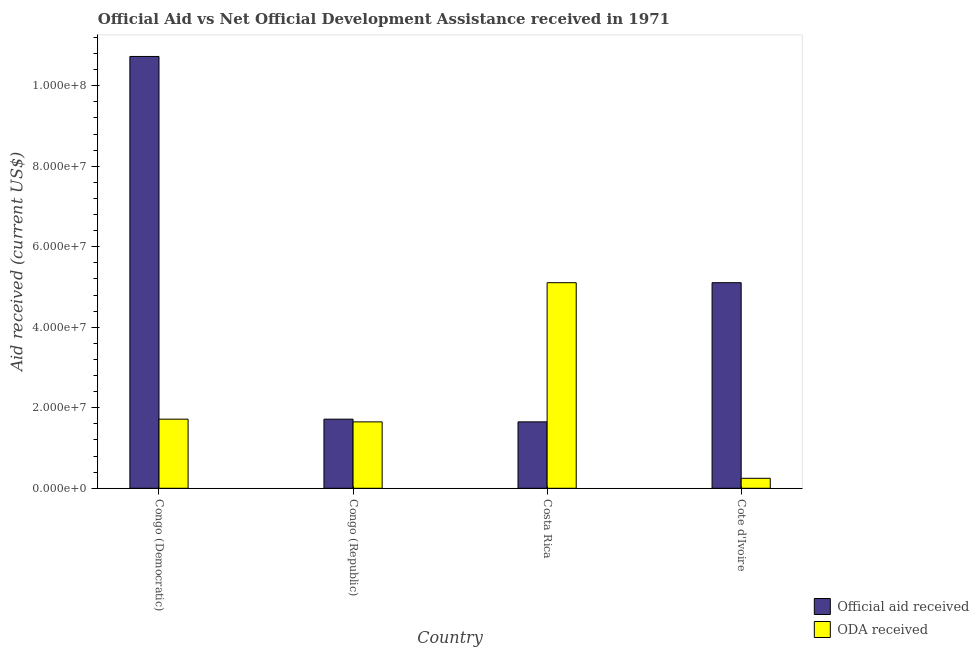How many different coloured bars are there?
Offer a terse response. 2. How many groups of bars are there?
Offer a terse response. 4. Are the number of bars on each tick of the X-axis equal?
Ensure brevity in your answer.  Yes. How many bars are there on the 1st tick from the left?
Your answer should be very brief. 2. What is the label of the 1st group of bars from the left?
Provide a succinct answer. Congo (Democratic). What is the official aid received in Congo (Republic)?
Ensure brevity in your answer.  1.72e+07. Across all countries, what is the maximum official aid received?
Keep it short and to the point. 1.07e+08. Across all countries, what is the minimum oda received?
Keep it short and to the point. 2.48e+06. In which country was the official aid received maximum?
Your answer should be very brief. Congo (Democratic). What is the total official aid received in the graph?
Provide a short and direct response. 1.92e+08. What is the difference between the official aid received in Congo (Republic) and that in Costa Rica?
Give a very brief answer. 6.70e+05. What is the average oda received per country?
Keep it short and to the point. 2.18e+07. What is the difference between the oda received and official aid received in Cote d'Ivoire?
Ensure brevity in your answer.  -4.86e+07. What is the ratio of the oda received in Costa Rica to that in Cote d'Ivoire?
Provide a succinct answer. 20.59. What is the difference between the highest and the second highest oda received?
Ensure brevity in your answer.  3.39e+07. What is the difference between the highest and the lowest oda received?
Give a very brief answer. 4.86e+07. In how many countries, is the official aid received greater than the average official aid received taken over all countries?
Your answer should be very brief. 2. Is the sum of the oda received in Congo (Democratic) and Cote d'Ivoire greater than the maximum official aid received across all countries?
Offer a very short reply. No. What does the 2nd bar from the left in Costa Rica represents?
Your response must be concise. ODA received. What does the 2nd bar from the right in Cote d'Ivoire represents?
Your answer should be compact. Official aid received. Does the graph contain any zero values?
Your answer should be very brief. No. Where does the legend appear in the graph?
Make the answer very short. Bottom right. What is the title of the graph?
Make the answer very short. Official Aid vs Net Official Development Assistance received in 1971 . What is the label or title of the X-axis?
Offer a terse response. Country. What is the label or title of the Y-axis?
Make the answer very short. Aid received (current US$). What is the Aid received (current US$) in Official aid received in Congo (Democratic)?
Provide a succinct answer. 1.07e+08. What is the Aid received (current US$) in ODA received in Congo (Democratic)?
Provide a succinct answer. 1.72e+07. What is the Aid received (current US$) of Official aid received in Congo (Republic)?
Provide a succinct answer. 1.72e+07. What is the Aid received (current US$) of ODA received in Congo (Republic)?
Make the answer very short. 1.65e+07. What is the Aid received (current US$) in Official aid received in Costa Rica?
Keep it short and to the point. 1.65e+07. What is the Aid received (current US$) in ODA received in Costa Rica?
Offer a very short reply. 5.11e+07. What is the Aid received (current US$) in Official aid received in Cote d'Ivoire?
Offer a very short reply. 5.11e+07. What is the Aid received (current US$) of ODA received in Cote d'Ivoire?
Your answer should be compact. 2.48e+06. Across all countries, what is the maximum Aid received (current US$) in Official aid received?
Provide a short and direct response. 1.07e+08. Across all countries, what is the maximum Aid received (current US$) in ODA received?
Your answer should be compact. 5.11e+07. Across all countries, what is the minimum Aid received (current US$) in Official aid received?
Provide a succinct answer. 1.65e+07. Across all countries, what is the minimum Aid received (current US$) of ODA received?
Your answer should be very brief. 2.48e+06. What is the total Aid received (current US$) in Official aid received in the graph?
Make the answer very short. 1.92e+08. What is the total Aid received (current US$) of ODA received in the graph?
Offer a very short reply. 8.72e+07. What is the difference between the Aid received (current US$) in Official aid received in Congo (Democratic) and that in Congo (Republic)?
Provide a short and direct response. 9.01e+07. What is the difference between the Aid received (current US$) of ODA received in Congo (Democratic) and that in Congo (Republic)?
Offer a very short reply. 6.70e+05. What is the difference between the Aid received (current US$) of Official aid received in Congo (Democratic) and that in Costa Rica?
Offer a terse response. 9.08e+07. What is the difference between the Aid received (current US$) in ODA received in Congo (Democratic) and that in Costa Rica?
Your response must be concise. -3.39e+07. What is the difference between the Aid received (current US$) in Official aid received in Congo (Democratic) and that in Cote d'Ivoire?
Keep it short and to the point. 5.62e+07. What is the difference between the Aid received (current US$) in ODA received in Congo (Democratic) and that in Cote d'Ivoire?
Give a very brief answer. 1.47e+07. What is the difference between the Aid received (current US$) of Official aid received in Congo (Republic) and that in Costa Rica?
Your answer should be compact. 6.70e+05. What is the difference between the Aid received (current US$) of ODA received in Congo (Republic) and that in Costa Rica?
Ensure brevity in your answer.  -3.46e+07. What is the difference between the Aid received (current US$) in Official aid received in Congo (Republic) and that in Cote d'Ivoire?
Make the answer very short. -3.39e+07. What is the difference between the Aid received (current US$) in ODA received in Congo (Republic) and that in Cote d'Ivoire?
Your answer should be very brief. 1.40e+07. What is the difference between the Aid received (current US$) of Official aid received in Costa Rica and that in Cote d'Ivoire?
Your response must be concise. -3.46e+07. What is the difference between the Aid received (current US$) of ODA received in Costa Rica and that in Cote d'Ivoire?
Provide a succinct answer. 4.86e+07. What is the difference between the Aid received (current US$) in Official aid received in Congo (Democratic) and the Aid received (current US$) in ODA received in Congo (Republic)?
Make the answer very short. 9.08e+07. What is the difference between the Aid received (current US$) in Official aid received in Congo (Democratic) and the Aid received (current US$) in ODA received in Costa Rica?
Your response must be concise. 5.62e+07. What is the difference between the Aid received (current US$) of Official aid received in Congo (Democratic) and the Aid received (current US$) of ODA received in Cote d'Ivoire?
Provide a succinct answer. 1.05e+08. What is the difference between the Aid received (current US$) of Official aid received in Congo (Republic) and the Aid received (current US$) of ODA received in Costa Rica?
Your response must be concise. -3.39e+07. What is the difference between the Aid received (current US$) in Official aid received in Congo (Republic) and the Aid received (current US$) in ODA received in Cote d'Ivoire?
Keep it short and to the point. 1.47e+07. What is the difference between the Aid received (current US$) of Official aid received in Costa Rica and the Aid received (current US$) of ODA received in Cote d'Ivoire?
Keep it short and to the point. 1.40e+07. What is the average Aid received (current US$) in Official aid received per country?
Give a very brief answer. 4.80e+07. What is the average Aid received (current US$) in ODA received per country?
Your answer should be compact. 2.18e+07. What is the difference between the Aid received (current US$) in Official aid received and Aid received (current US$) in ODA received in Congo (Democratic)?
Your answer should be very brief. 9.01e+07. What is the difference between the Aid received (current US$) of Official aid received and Aid received (current US$) of ODA received in Congo (Republic)?
Make the answer very short. 6.70e+05. What is the difference between the Aid received (current US$) of Official aid received and Aid received (current US$) of ODA received in Costa Rica?
Your answer should be very brief. -3.46e+07. What is the difference between the Aid received (current US$) in Official aid received and Aid received (current US$) in ODA received in Cote d'Ivoire?
Offer a very short reply. 4.86e+07. What is the ratio of the Aid received (current US$) in Official aid received in Congo (Democratic) to that in Congo (Republic)?
Offer a very short reply. 6.25. What is the ratio of the Aid received (current US$) in ODA received in Congo (Democratic) to that in Congo (Republic)?
Give a very brief answer. 1.04. What is the ratio of the Aid received (current US$) in Official aid received in Congo (Democratic) to that in Costa Rica?
Give a very brief answer. 6.5. What is the ratio of the Aid received (current US$) of ODA received in Congo (Democratic) to that in Costa Rica?
Make the answer very short. 0.34. What is the ratio of the Aid received (current US$) in Official aid received in Congo (Democratic) to that in Cote d'Ivoire?
Keep it short and to the point. 2.1. What is the ratio of the Aid received (current US$) in ODA received in Congo (Democratic) to that in Cote d'Ivoire?
Provide a short and direct response. 6.92. What is the ratio of the Aid received (current US$) in Official aid received in Congo (Republic) to that in Costa Rica?
Provide a short and direct response. 1.04. What is the ratio of the Aid received (current US$) of ODA received in Congo (Republic) to that in Costa Rica?
Ensure brevity in your answer.  0.32. What is the ratio of the Aid received (current US$) in Official aid received in Congo (Republic) to that in Cote d'Ivoire?
Make the answer very short. 0.34. What is the ratio of the Aid received (current US$) of ODA received in Congo (Republic) to that in Cote d'Ivoire?
Ensure brevity in your answer.  6.65. What is the ratio of the Aid received (current US$) of Official aid received in Costa Rica to that in Cote d'Ivoire?
Offer a very short reply. 0.32. What is the ratio of the Aid received (current US$) in ODA received in Costa Rica to that in Cote d'Ivoire?
Provide a succinct answer. 20.59. What is the difference between the highest and the second highest Aid received (current US$) in Official aid received?
Offer a very short reply. 5.62e+07. What is the difference between the highest and the second highest Aid received (current US$) in ODA received?
Keep it short and to the point. 3.39e+07. What is the difference between the highest and the lowest Aid received (current US$) in Official aid received?
Keep it short and to the point. 9.08e+07. What is the difference between the highest and the lowest Aid received (current US$) in ODA received?
Provide a succinct answer. 4.86e+07. 